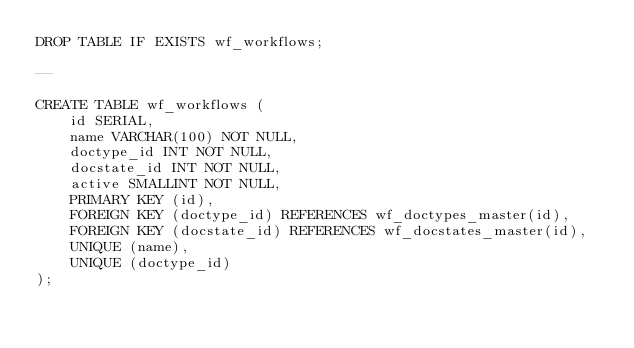Convert code to text. <code><loc_0><loc_0><loc_500><loc_500><_SQL_>DROP TABLE IF EXISTS wf_workflows;

--

CREATE TABLE wf_workflows (
    id SERIAL,
    name VARCHAR(100) NOT NULL,
    doctype_id INT NOT NULL,
    docstate_id INT NOT NULL,
    active SMALLINT NOT NULL,
    PRIMARY KEY (id),
    FOREIGN KEY (doctype_id) REFERENCES wf_doctypes_master(id),
    FOREIGN KEY (docstate_id) REFERENCES wf_docstates_master(id),
    UNIQUE (name),
    UNIQUE (doctype_id)
);
</code> 